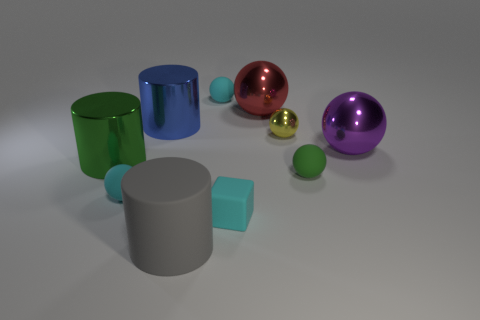Are there any big blue things made of the same material as the red object?
Offer a very short reply. Yes. Is the number of small objects to the left of the big purple metallic thing greater than the number of small balls that are to the right of the large red object?
Provide a succinct answer. Yes. Do the yellow metal object and the cyan rubber cube have the same size?
Offer a very short reply. Yes. What is the color of the large ball behind the big metallic ball that is to the right of the red metal thing?
Your answer should be very brief. Red. What color is the big rubber cylinder?
Keep it short and to the point. Gray. Are there any small balls of the same color as the big matte cylinder?
Your answer should be compact. No. Does the small matte sphere that is behind the big green metallic thing have the same color as the large rubber thing?
Your response must be concise. No. How many things are either cyan rubber balls left of the gray rubber cylinder or big objects?
Offer a very short reply. 6. There is a small block; are there any small cubes in front of it?
Provide a succinct answer. No. Do the big cylinder that is behind the large purple sphere and the small green ball have the same material?
Keep it short and to the point. No. 